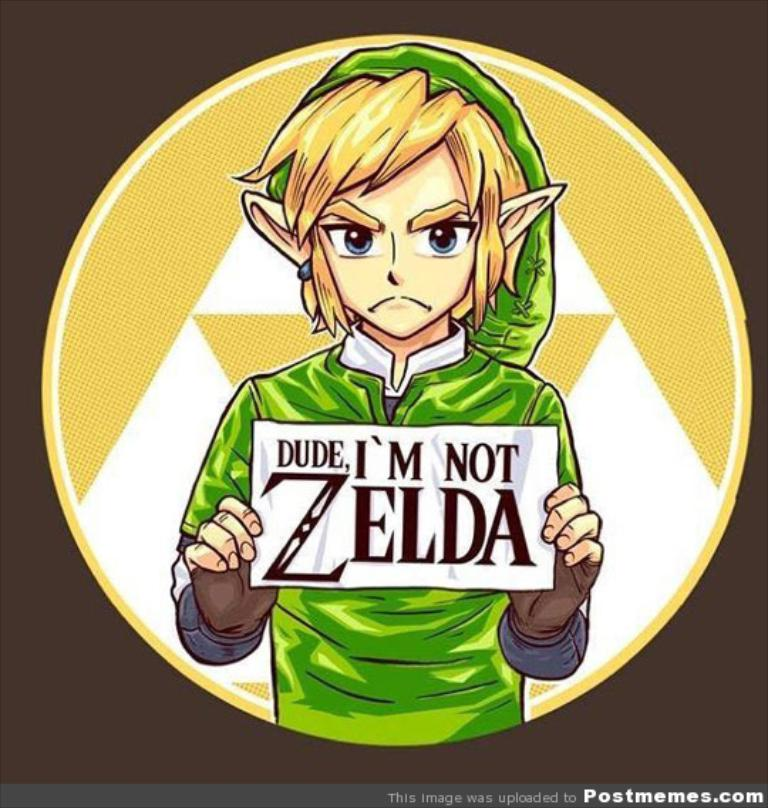Did Link ever physically display misunderstanding about his own identity in the games? In the games, Link does not explicitly address misunderstandings about his identity. The games focus more on his actions and adventures rather than identity commentary, but this image humorously brings attention to how commonly he is mistaken for Zelda, who is actually a different key character in the series. 